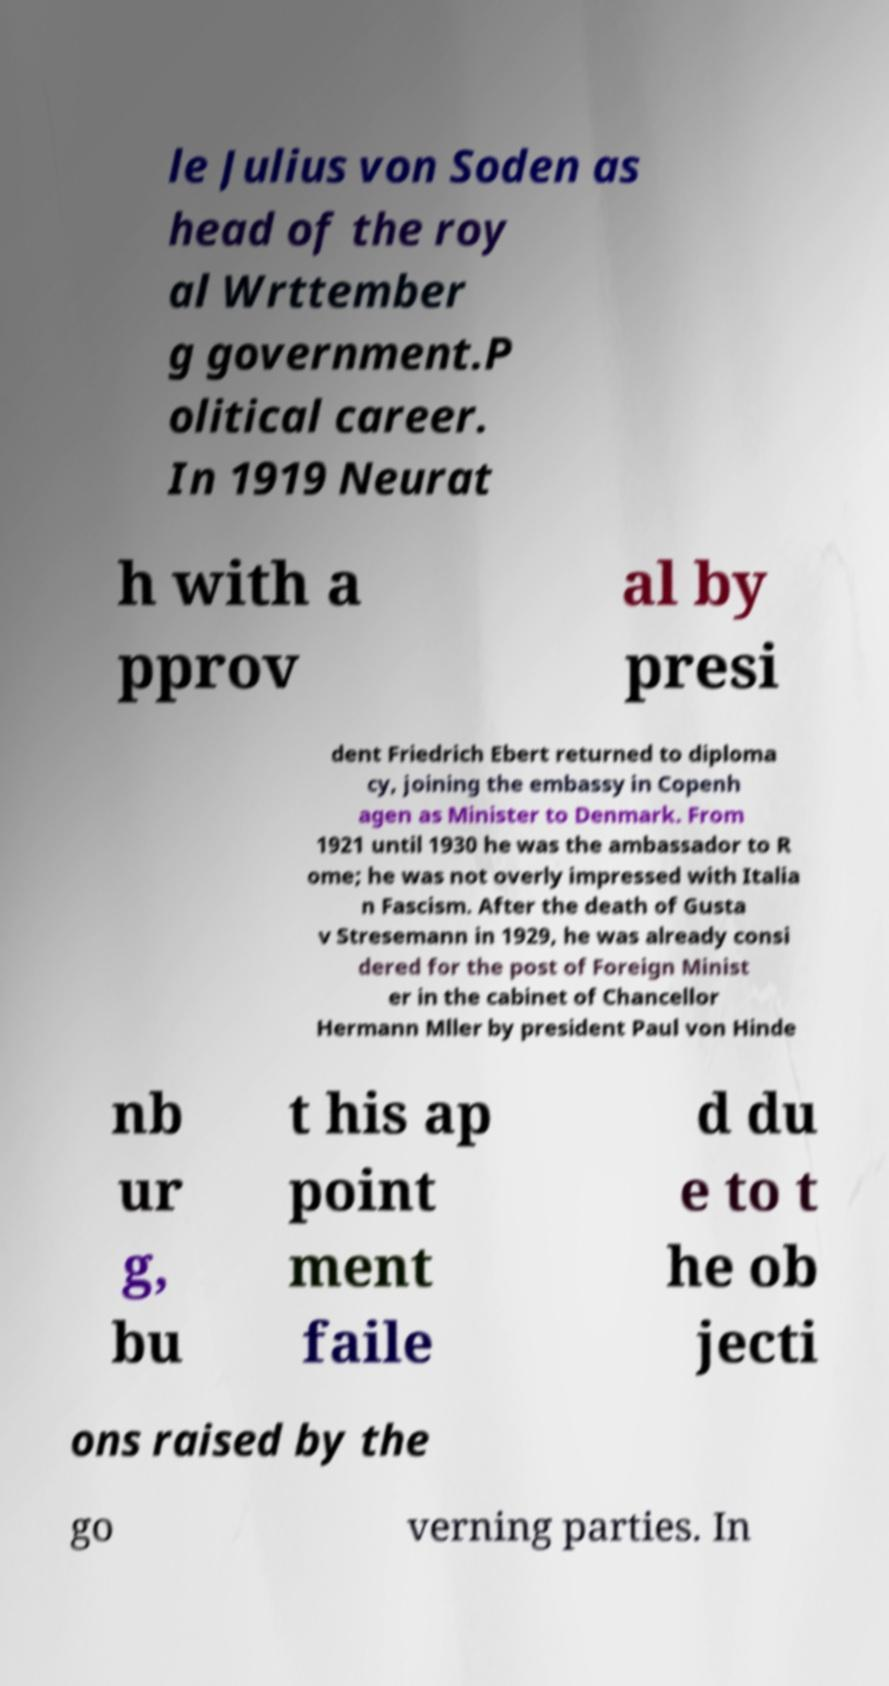Please identify and transcribe the text found in this image. le Julius von Soden as head of the roy al Wrttember g government.P olitical career. In 1919 Neurat h with a pprov al by presi dent Friedrich Ebert returned to diploma cy, joining the embassy in Copenh agen as Minister to Denmark. From 1921 until 1930 he was the ambassador to R ome; he was not overly impressed with Italia n Fascism. After the death of Gusta v Stresemann in 1929, he was already consi dered for the post of Foreign Minist er in the cabinet of Chancellor Hermann Mller by president Paul von Hinde nb ur g, bu t his ap point ment faile d du e to t he ob jecti ons raised by the go verning parties. In 